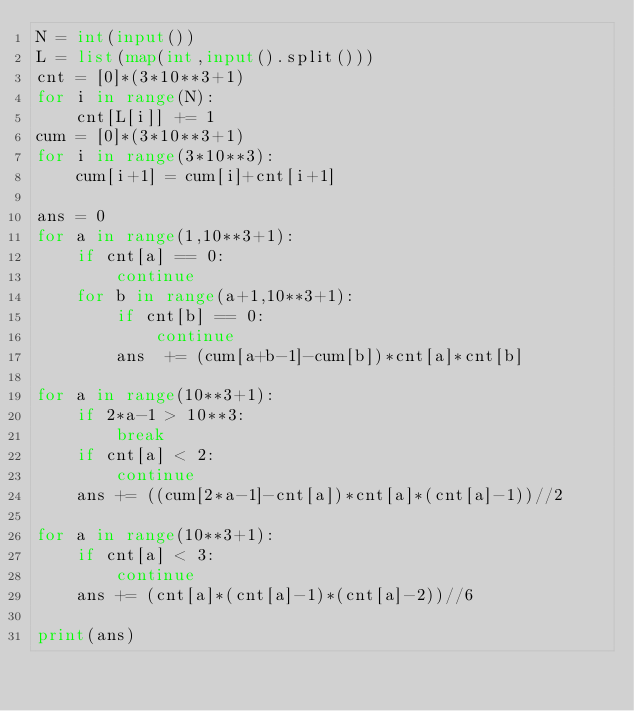Convert code to text. <code><loc_0><loc_0><loc_500><loc_500><_Python_>N = int(input())
L = list(map(int,input().split()))
cnt = [0]*(3*10**3+1)
for i in range(N):
    cnt[L[i]] += 1
cum = [0]*(3*10**3+1)
for i in range(3*10**3):
    cum[i+1] = cum[i]+cnt[i+1]

ans = 0
for a in range(1,10**3+1):
    if cnt[a] == 0:
        continue
    for b in range(a+1,10**3+1):
        if cnt[b] == 0:
            continue
        ans  += (cum[a+b-1]-cum[b])*cnt[a]*cnt[b]

for a in range(10**3+1):
    if 2*a-1 > 10**3:
        break
    if cnt[a] < 2:
        continue
    ans += ((cum[2*a-1]-cnt[a])*cnt[a]*(cnt[a]-1))//2

for a in range(10**3+1):
    if cnt[a] < 3:
        continue
    ans += (cnt[a]*(cnt[a]-1)*(cnt[a]-2))//6

print(ans)</code> 